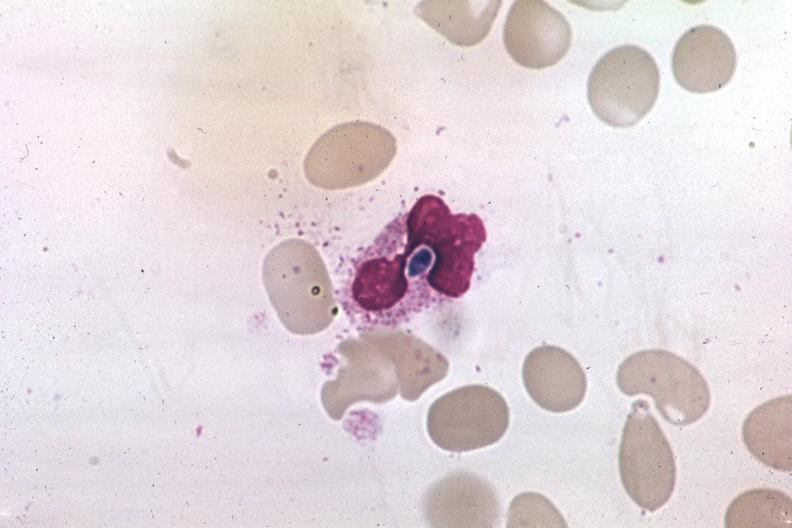s blood present?
Answer the question using a single word or phrase. Yes 